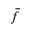Convert formula to latex. <formula><loc_0><loc_0><loc_500><loc_500>\bar { f }</formula> 